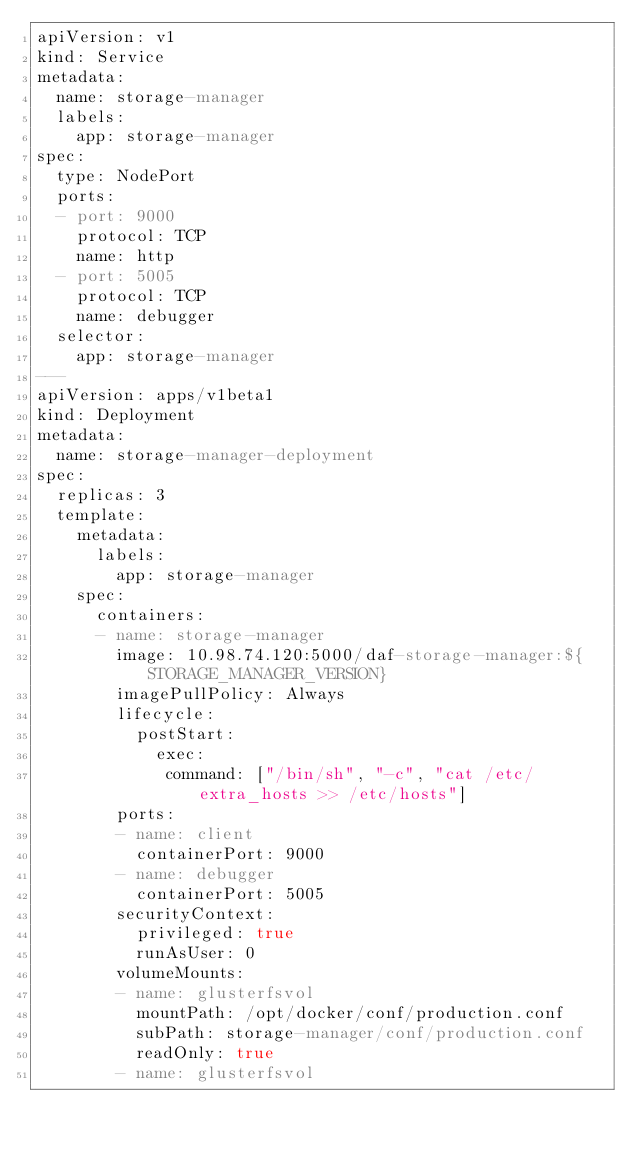<code> <loc_0><loc_0><loc_500><loc_500><_YAML_>apiVersion: v1
kind: Service
metadata:
  name: storage-manager
  labels:
    app: storage-manager
spec:
  type: NodePort
  ports:
  - port: 9000
    protocol: TCP
    name: http
  - port: 5005
    protocol: TCP
    name: debugger
  selector:
    app: storage-manager
---
apiVersion: apps/v1beta1
kind: Deployment
metadata:
  name: storage-manager-deployment
spec:
  replicas: 3
  template:
    metadata:
      labels:
        app: storage-manager
    spec:
      containers:
      - name: storage-manager
        image: 10.98.74.120:5000/daf-storage-manager:${STORAGE_MANAGER_VERSION}
        imagePullPolicy: Always
        lifecycle:
          postStart:
            exec:
             command: ["/bin/sh", "-c", "cat /etc/extra_hosts >> /etc/hosts"]
        ports:
        - name: client
          containerPort: 9000
        - name: debugger
          containerPort: 5005
        securityContext:
          privileged: true
          runAsUser: 0
        volumeMounts:
        - name: glusterfsvol
          mountPath: /opt/docker/conf/production.conf
          subPath: storage-manager/conf/production.conf
          readOnly: true
        - name: glusterfsvol</code> 